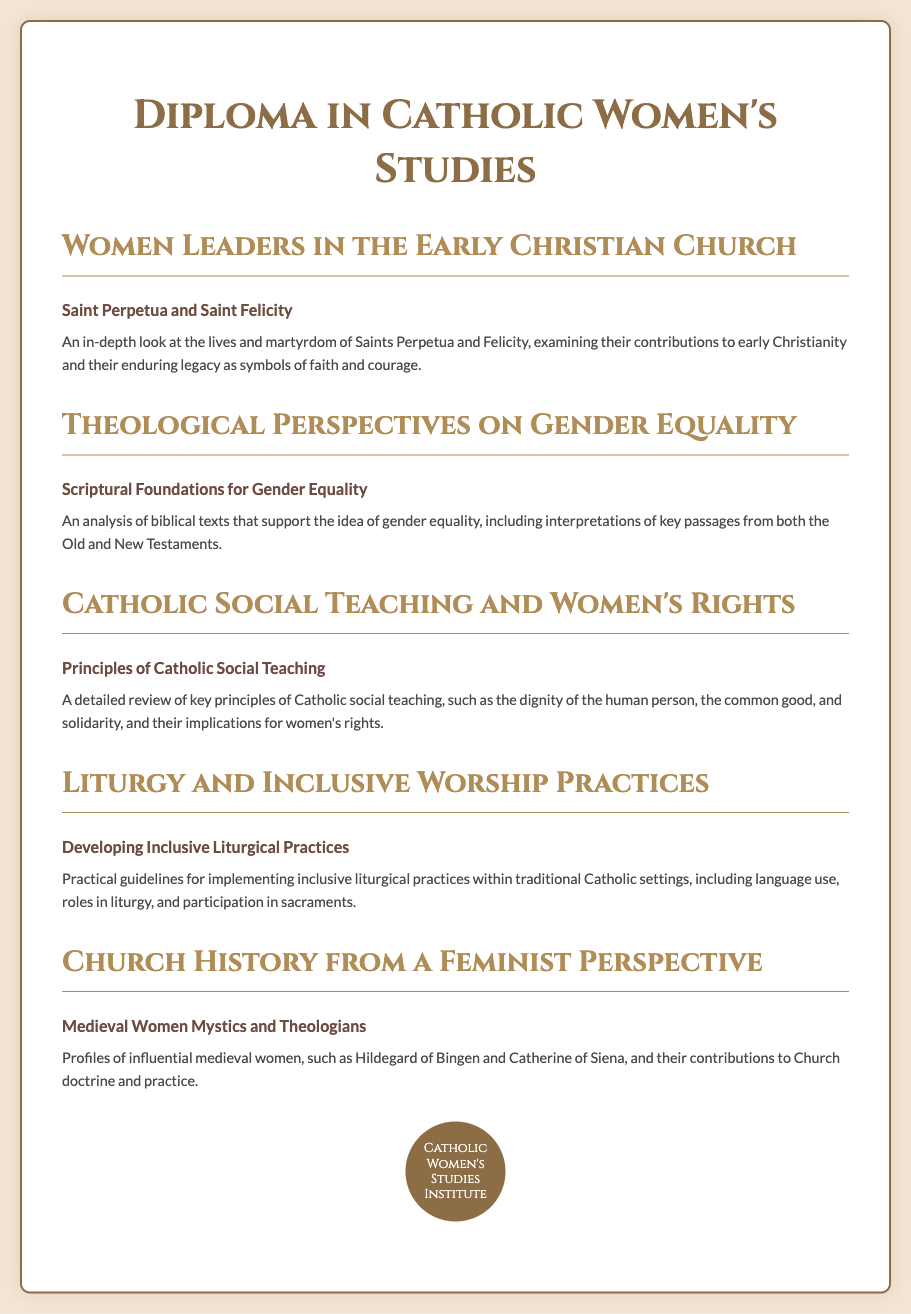What is the main title of the diploma? The main title of the diploma is stated clearly at the top of the document.
Answer: Diploma in Catholic Women's Studies Who are the two saints highlighted in the women leaders course? The document specifically names these two saints in the course description for a deeper understanding of their contributions.
Answer: Saints Perpetua and Felicity What theological aspect does the second course focus on? The second course's title indicates its focus on a particular theological argument related to equality.
Answer: Gender Equality Name one principle of Catholic Social Teaching discussed in the women's rights course. The course title mentions key principles related to social justice for women.
Answer: Dignity of the human person Which medieval women are profiled in the church history course? The course description specifies notable figures whose contributions are analyzed.
Answer: Hildegard of Bingen and Catherine of Siena What is one aspect covered in the inclusive worship practices course? The course content mentions guidelines for how to implement specific practices in liturgy, indicating a broader theme of inclusivity.
Answer: Language use How many courses are listed in the diploma program? By counting the course headings in the document, we can determine the total number of courses provided.
Answer: Five 